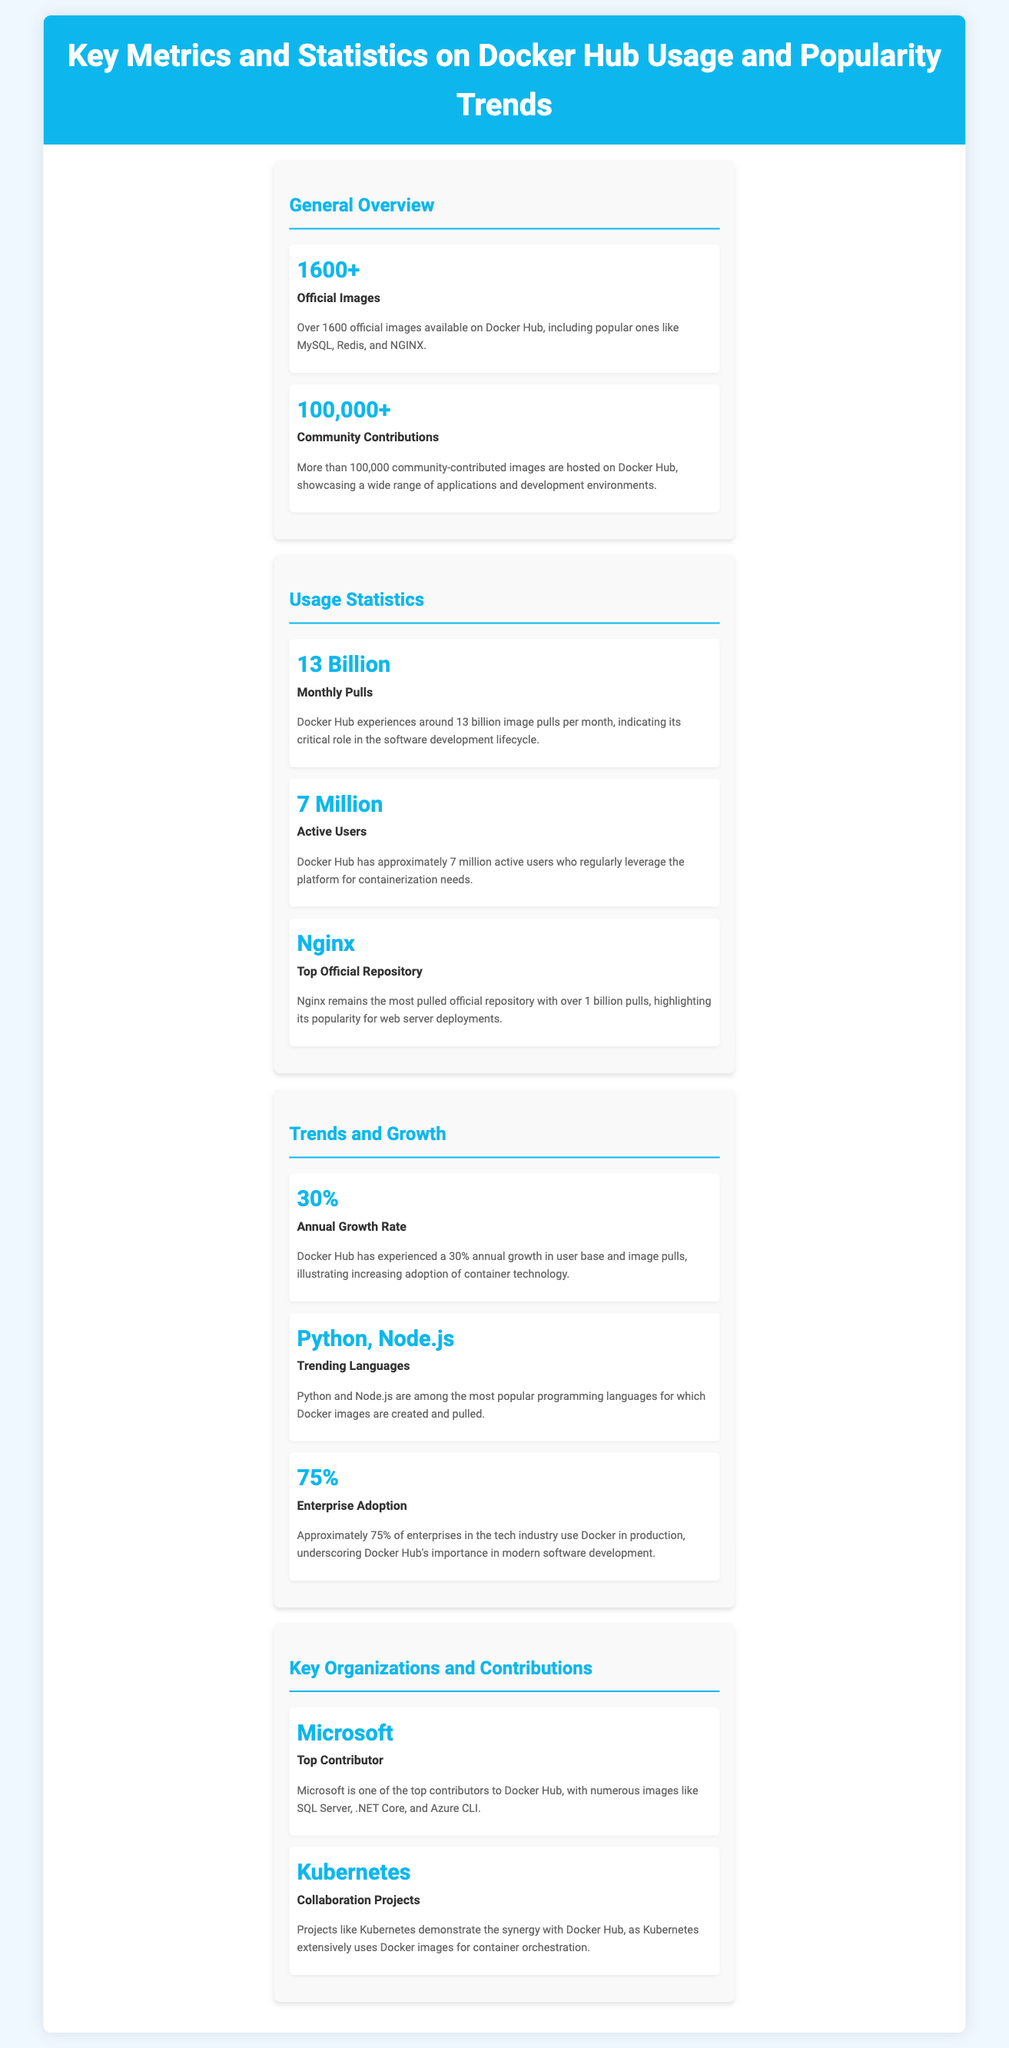What is the number of official images on Docker Hub? The document states that there are over 1600 official images available on Docker Hub.
Answer: 1600+ What is the total number of community contributions? The infographic indicates that more than 100,000 community-contributed images are hosted on Docker Hub.
Answer: 100,000+ How many monthly pulls does Docker Hub experience? According to the document, Docker Hub experiences around 13 billion image pulls per month.
Answer: 13 Billion What is the annual growth rate of Docker Hub? The document mentions that Docker Hub has experienced a 30% annual growth in user base and image pulls.
Answer: 30% Which official repository is the most pulled? The infographic states that Nginx remains the most pulled official repository.
Answer: Nginx How many active users does Docker Hub have? The document notes that Docker Hub has approximately 7 million active users.
Answer: 7 Million What percentage of enterprises use Docker in production? The infographic indicates that approximately 75% of enterprises in the tech industry use Docker in production.
Answer: 75% Which programming languages are trending on Docker Hub? The document lists Python and Node.js as the most popular programming languages for which Docker images are created.
Answer: Python, Node.js Who is mentioned as the top contributor? The infographic mentions Microsoft as one of the top contributors to Docker Hub.
Answer: Microsoft 